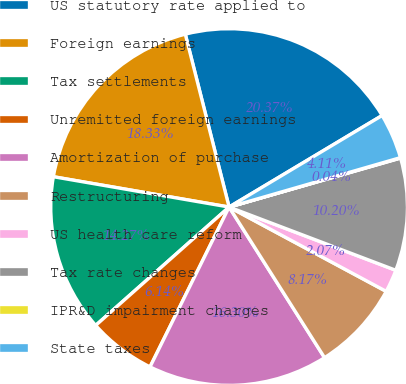Convert chart to OTSL. <chart><loc_0><loc_0><loc_500><loc_500><pie_chart><fcel>US statutory rate applied to<fcel>Foreign earnings<fcel>Tax settlements<fcel>Unremitted foreign earnings<fcel>Amortization of purchase<fcel>Restructuring<fcel>US health care reform<fcel>Tax rate changes<fcel>IPR&D impairment charges<fcel>State taxes<nl><fcel>20.37%<fcel>18.33%<fcel>14.27%<fcel>6.14%<fcel>16.3%<fcel>8.17%<fcel>2.07%<fcel>10.2%<fcel>0.04%<fcel>4.11%<nl></chart> 